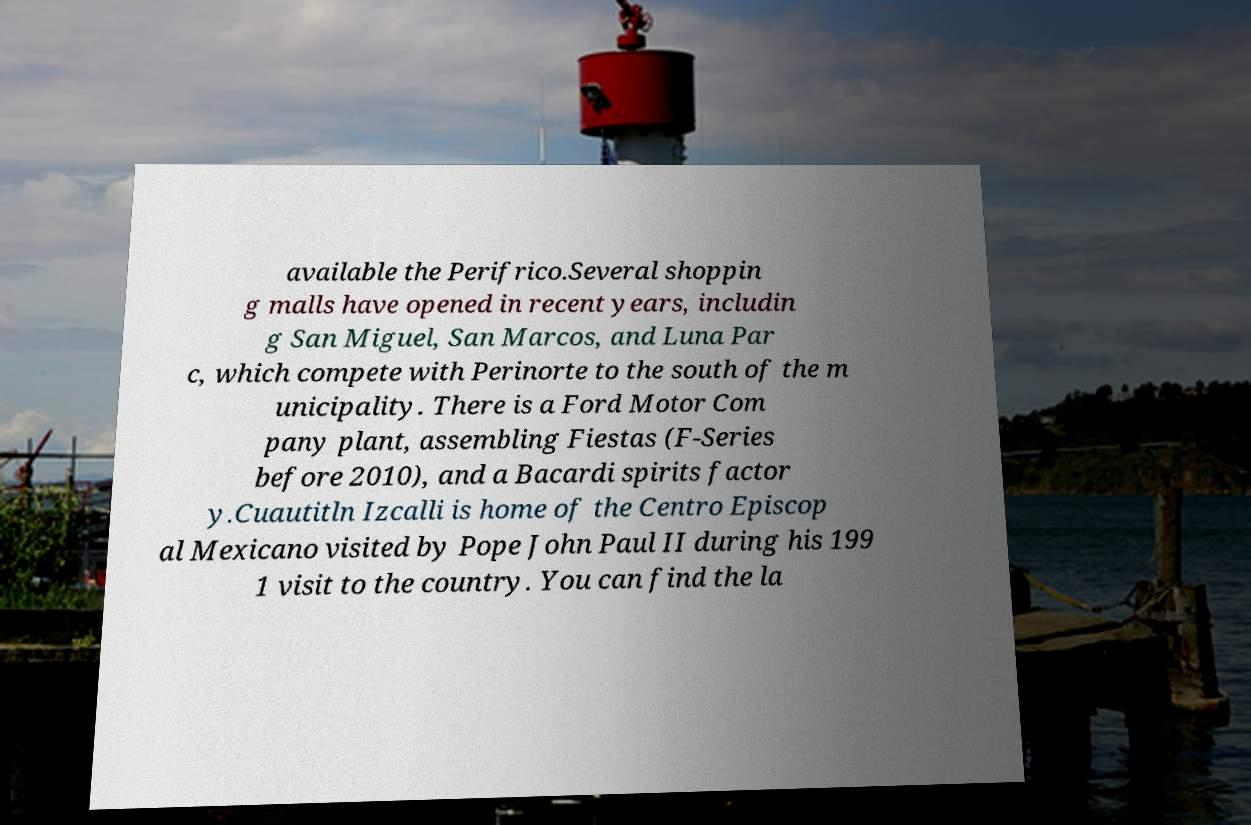I need the written content from this picture converted into text. Can you do that? available the Perifrico.Several shoppin g malls have opened in recent years, includin g San Miguel, San Marcos, and Luna Par c, which compete with Perinorte to the south of the m unicipality. There is a Ford Motor Com pany plant, assembling Fiestas (F-Series before 2010), and a Bacardi spirits factor y.Cuautitln Izcalli is home of the Centro Episcop al Mexicano visited by Pope John Paul II during his 199 1 visit to the country. You can find the la 